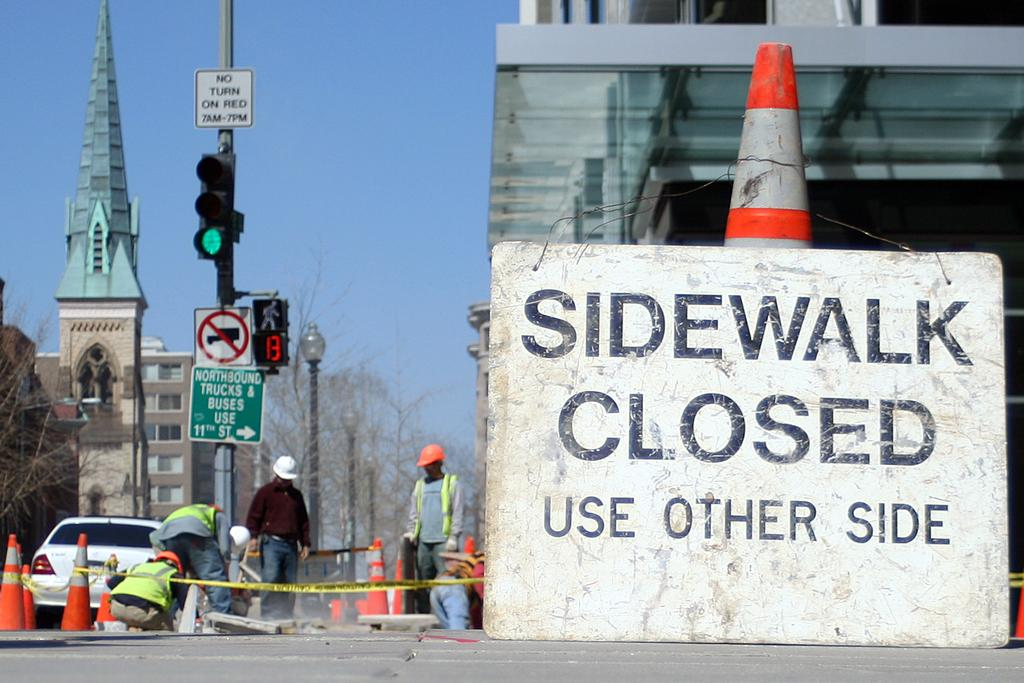<image>
Share a concise interpretation of the image provided. Construction workers are working on a street and a sign in front says the sidewalk is closed and to use the other side. 